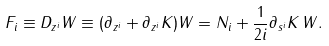Convert formula to latex. <formula><loc_0><loc_0><loc_500><loc_500>F _ { i } \equiv D _ { z ^ { i } } W \equiv ( \partial _ { z ^ { i } } + \partial _ { z ^ { i } } K ) W = N _ { i } + \frac { 1 } { 2 i } \partial _ { s ^ { i } } K \, W .</formula> 